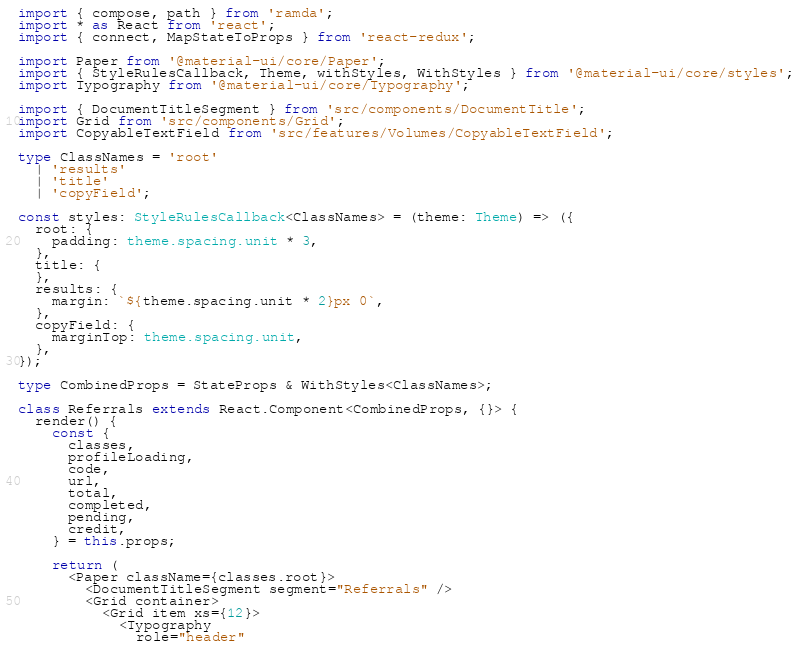<code> <loc_0><loc_0><loc_500><loc_500><_TypeScript_>import { compose, path } from 'ramda';
import * as React from 'react';
import { connect, MapStateToProps } from 'react-redux';

import Paper from '@material-ui/core/Paper';
import { StyleRulesCallback, Theme, withStyles, WithStyles } from '@material-ui/core/styles';
import Typography from '@material-ui/core/Typography';

import { DocumentTitleSegment } from 'src/components/DocumentTitle';
import Grid from 'src/components/Grid';
import CopyableTextField from 'src/features/Volumes/CopyableTextField';

type ClassNames = 'root'
  | 'results'
  | 'title'
  | 'copyField';

const styles: StyleRulesCallback<ClassNames> = (theme: Theme) => ({
  root: {
    padding: theme.spacing.unit * 3,
  },
  title: {
  },
  results: {
    margin: `${theme.spacing.unit * 2}px 0`,
  },
  copyField: {
    marginTop: theme.spacing.unit,
  },
});

type CombinedProps = StateProps & WithStyles<ClassNames>;

class Referrals extends React.Component<CombinedProps, {}> {
  render() {
    const {
      classes,
      profileLoading,
      code,
      url,
      total,
      completed,
      pending,
      credit,
    } = this.props;

    return (
      <Paper className={classes.root}>
        <DocumentTitleSegment segment="Referrals" />
        <Grid container>
          <Grid item xs={12}>
            <Typography
              role="header"</code> 